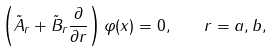Convert formula to latex. <formula><loc_0><loc_0><loc_500><loc_500>\left ( \tilde { A } _ { r } + \tilde { B } _ { r } \frac { \partial } { \partial r } \right ) \varphi ( x ) = 0 , \quad r = a , b ,</formula> 